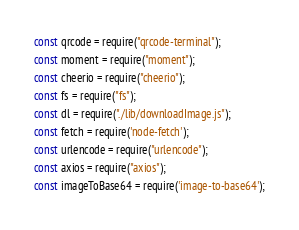Convert code to text. <code><loc_0><loc_0><loc_500><loc_500><_JavaScript_>const qrcode = require("qrcode-terminal");
const moment = require("moment");
const cheerio = require("cheerio");
const fs = require("fs");
const dl = require("./lib/downloadImage.js");
const fetch = require('node-fetch');
const urlencode = require("urlencode");
const axios = require("axios");
const imageToBase64 = require('image-to-base64');</code> 